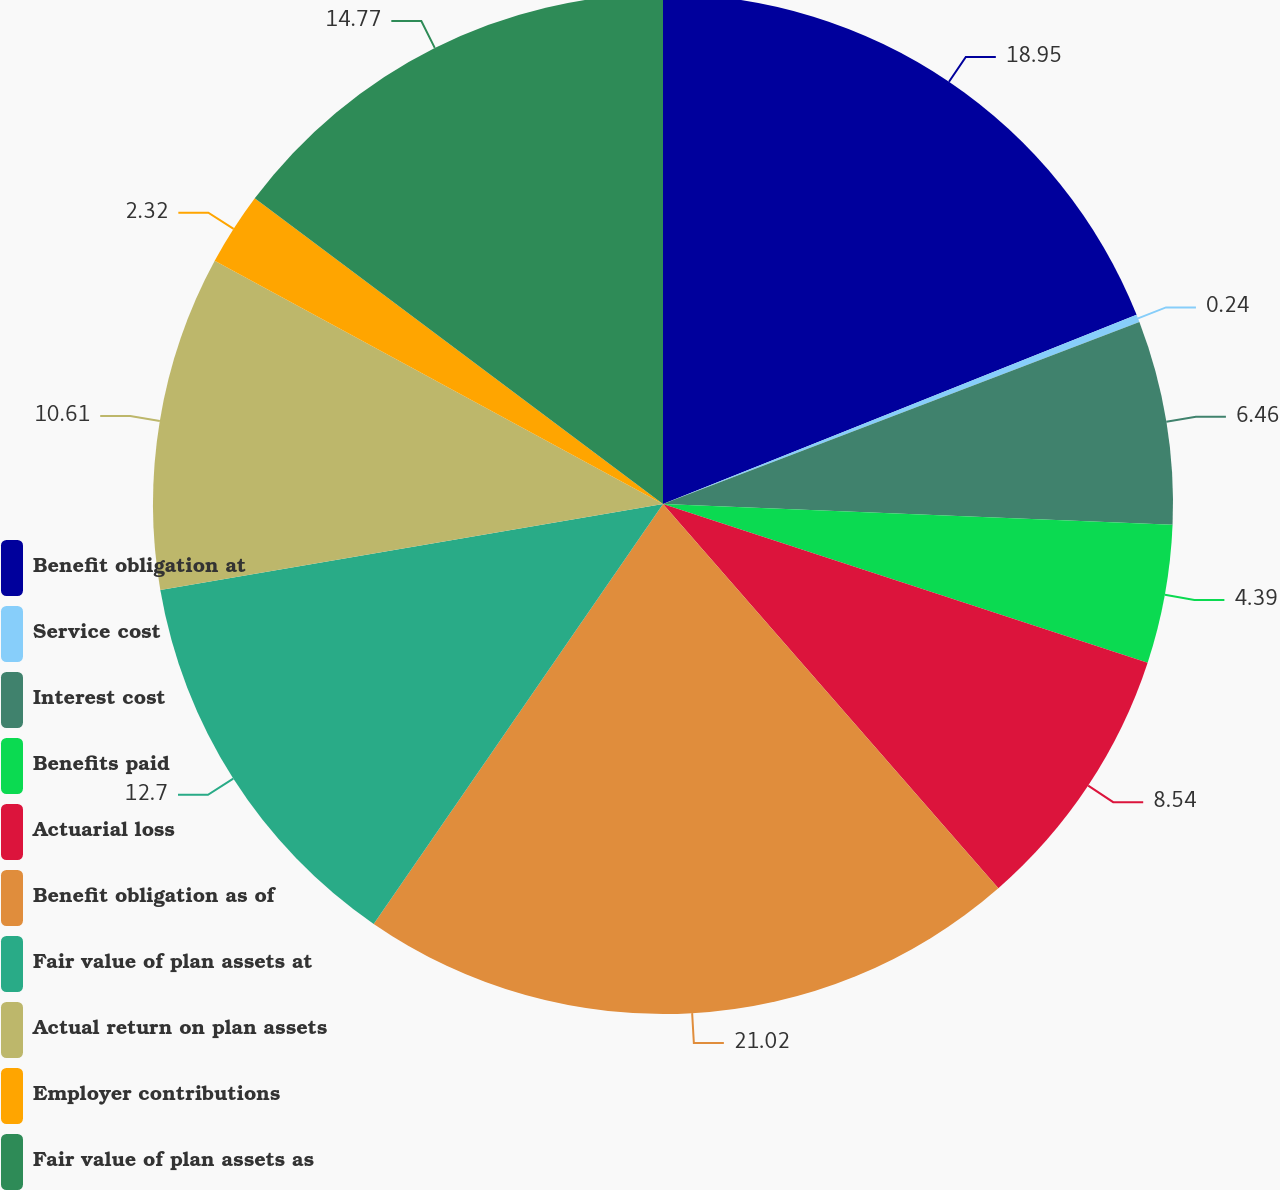Convert chart to OTSL. <chart><loc_0><loc_0><loc_500><loc_500><pie_chart><fcel>Benefit obligation at<fcel>Service cost<fcel>Interest cost<fcel>Benefits paid<fcel>Actuarial loss<fcel>Benefit obligation as of<fcel>Fair value of plan assets at<fcel>Actual return on plan assets<fcel>Employer contributions<fcel>Fair value of plan assets as<nl><fcel>18.95%<fcel>0.24%<fcel>6.46%<fcel>4.39%<fcel>8.54%<fcel>21.02%<fcel>12.7%<fcel>10.61%<fcel>2.32%<fcel>14.77%<nl></chart> 